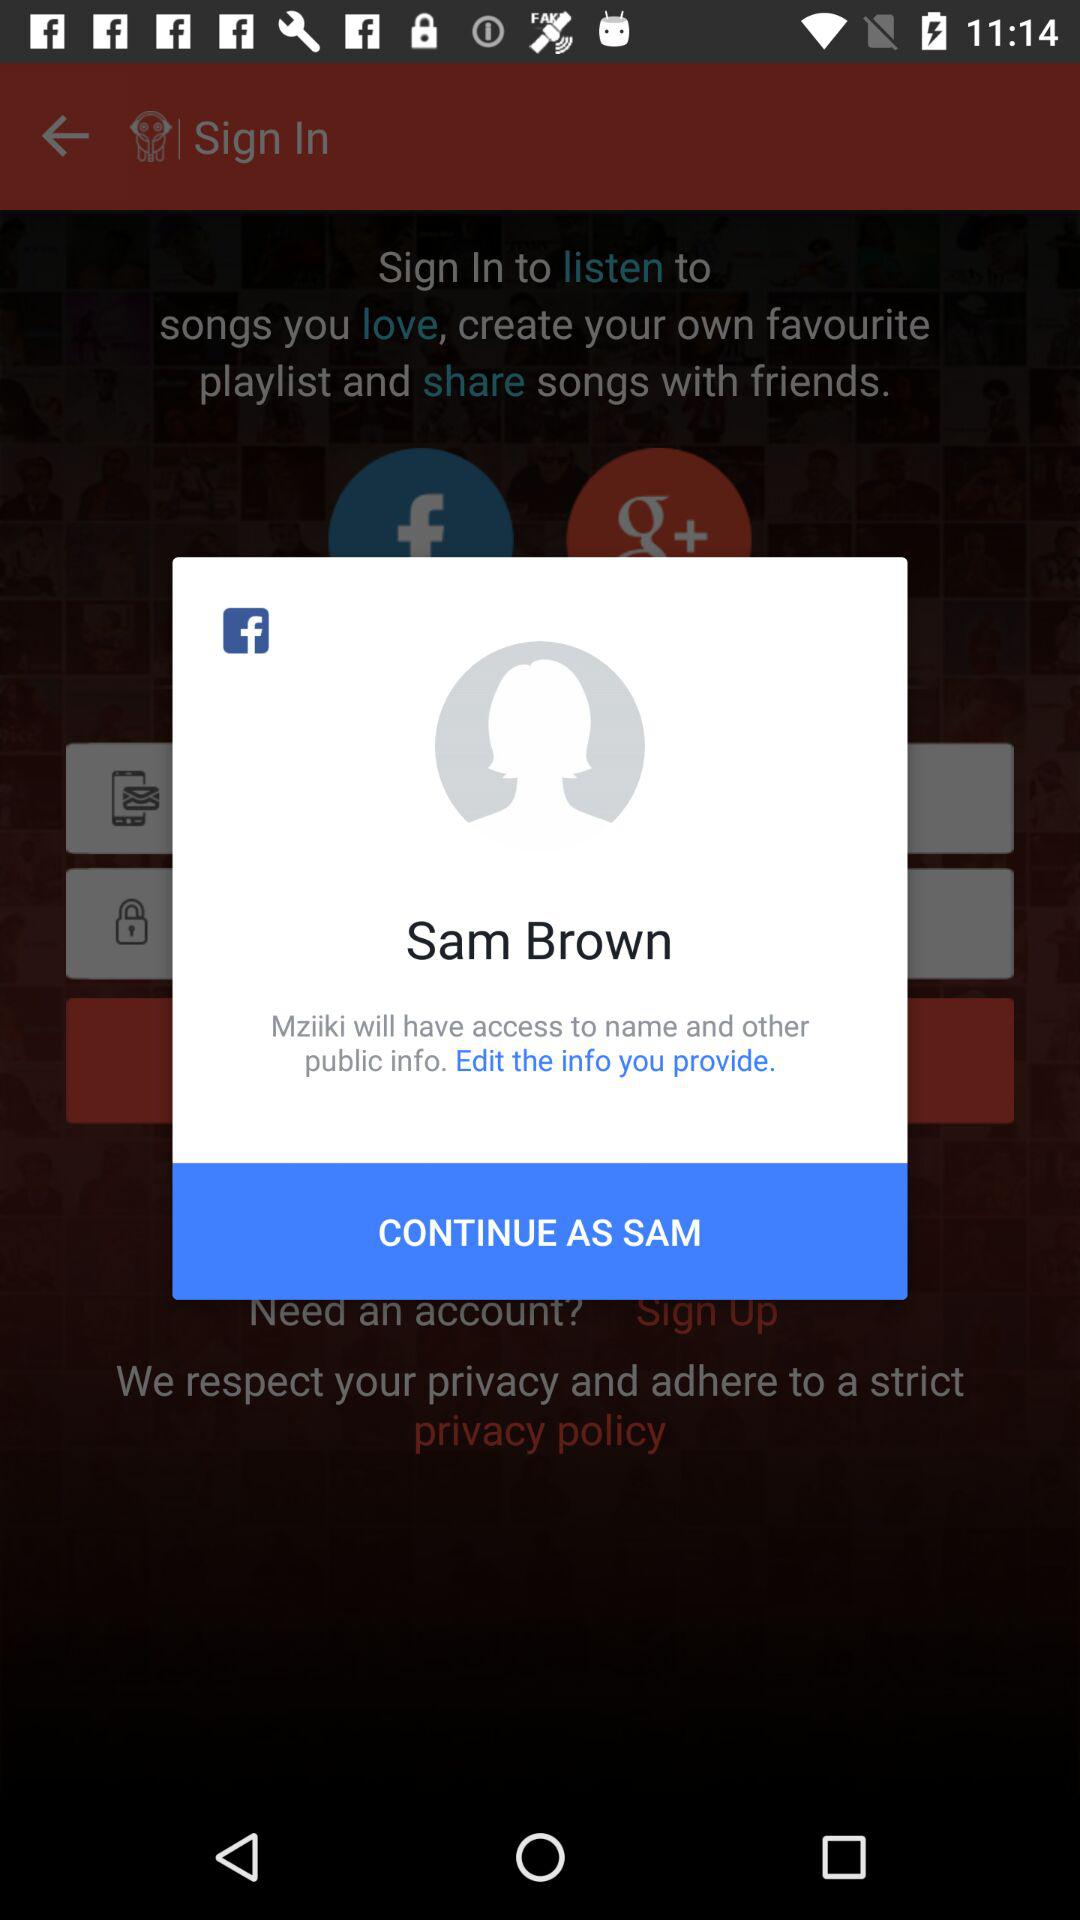What application can I use to log in to the profile? The application that you can use to log in to the profile is "Facebook". 